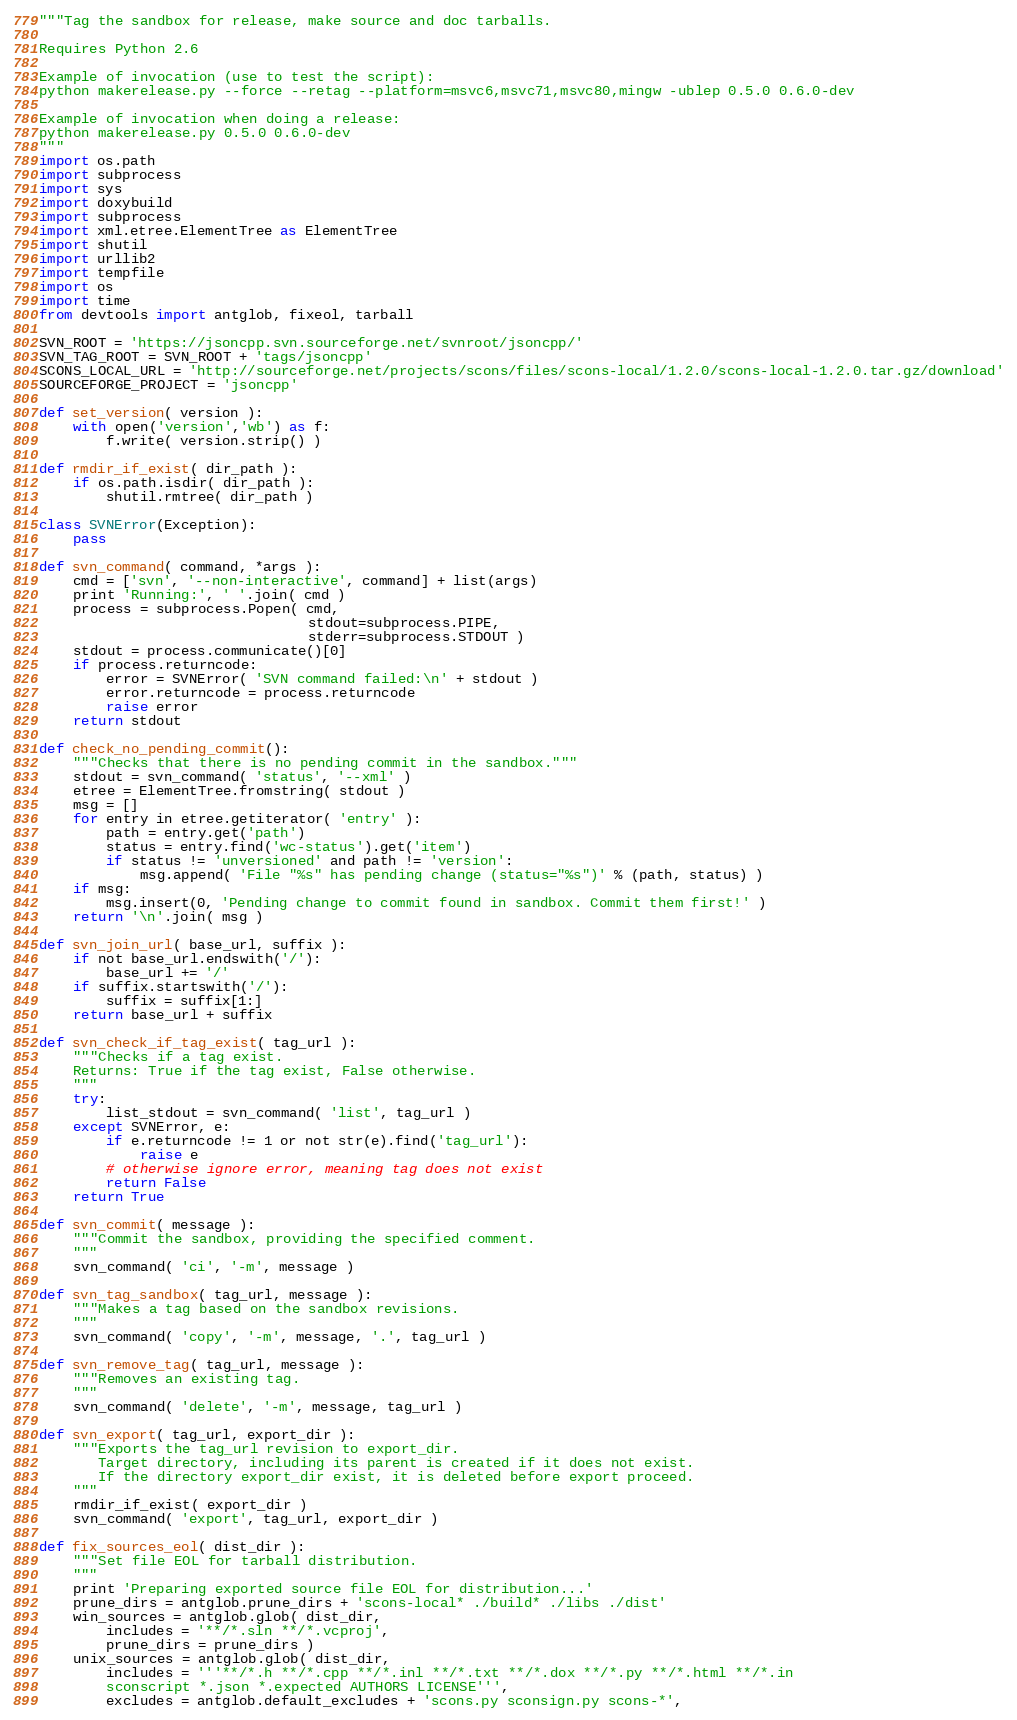Convert code to text. <code><loc_0><loc_0><loc_500><loc_500><_Python_>"""Tag the sandbox for release, make source and doc tarballs.

Requires Python 2.6

Example of invocation (use to test the script):
python makerelease.py --force --retag --platform=msvc6,msvc71,msvc80,mingw -ublep 0.5.0 0.6.0-dev

Example of invocation when doing a release:
python makerelease.py 0.5.0 0.6.0-dev
"""
import os.path
import subprocess
import sys
import doxybuild
import subprocess
import xml.etree.ElementTree as ElementTree
import shutil
import urllib2
import tempfile
import os
import time
from devtools import antglob, fixeol, tarball

SVN_ROOT = 'https://jsoncpp.svn.sourceforge.net/svnroot/jsoncpp/'
SVN_TAG_ROOT = SVN_ROOT + 'tags/jsoncpp'
SCONS_LOCAL_URL = 'http://sourceforge.net/projects/scons/files/scons-local/1.2.0/scons-local-1.2.0.tar.gz/download'
SOURCEFORGE_PROJECT = 'jsoncpp'

def set_version( version ):
    with open('version','wb') as f:
        f.write( version.strip() )

def rmdir_if_exist( dir_path ):
    if os.path.isdir( dir_path ):
        shutil.rmtree( dir_path )

class SVNError(Exception):
    pass

def svn_command( command, *args ):
    cmd = ['svn', '--non-interactive', command] + list(args)
    print 'Running:', ' '.join( cmd )
    process = subprocess.Popen( cmd,
                                stdout=subprocess.PIPE,
                                stderr=subprocess.STDOUT )
    stdout = process.communicate()[0]
    if process.returncode:
        error = SVNError( 'SVN command failed:\n' + stdout )
        error.returncode = process.returncode
        raise error
    return stdout

def check_no_pending_commit():
    """Checks that there is no pending commit in the sandbox."""
    stdout = svn_command( 'status', '--xml' )
    etree = ElementTree.fromstring( stdout )
    msg = []
    for entry in etree.getiterator( 'entry' ):
        path = entry.get('path')
        status = entry.find('wc-status').get('item')
        if status != 'unversioned' and path != 'version':
            msg.append( 'File "%s" has pending change (status="%s")' % (path, status) )
    if msg:
        msg.insert(0, 'Pending change to commit found in sandbox. Commit them first!' )
    return '\n'.join( msg )

def svn_join_url( base_url, suffix ):
    if not base_url.endswith('/'):
        base_url += '/'
    if suffix.startswith('/'):
        suffix = suffix[1:]
    return base_url + suffix

def svn_check_if_tag_exist( tag_url ):
    """Checks if a tag exist.
    Returns: True if the tag exist, False otherwise.
    """
    try:
        list_stdout = svn_command( 'list', tag_url )
    except SVNError, e:
        if e.returncode != 1 or not str(e).find('tag_url'):
            raise e
        # otherwise ignore error, meaning tag does not exist
        return False
    return True

def svn_commit( message ):
    """Commit the sandbox, providing the specified comment.
    """
    svn_command( 'ci', '-m', message )

def svn_tag_sandbox( tag_url, message ):
    """Makes a tag based on the sandbox revisions.
    """
    svn_command( 'copy', '-m', message, '.', tag_url )

def svn_remove_tag( tag_url, message ):
    """Removes an existing tag.
    """
    svn_command( 'delete', '-m', message, tag_url )

def svn_export( tag_url, export_dir ):
    """Exports the tag_url revision to export_dir.
       Target directory, including its parent is created if it does not exist.
       If the directory export_dir exist, it is deleted before export proceed.
    """
    rmdir_if_exist( export_dir )
    svn_command( 'export', tag_url, export_dir )

def fix_sources_eol( dist_dir ):
    """Set file EOL for tarball distribution.
    """
    print 'Preparing exported source file EOL for distribution...'
    prune_dirs = antglob.prune_dirs + 'scons-local* ./build* ./libs ./dist'
    win_sources = antglob.glob( dist_dir, 
        includes = '**/*.sln **/*.vcproj',
        prune_dirs = prune_dirs )
    unix_sources = antglob.glob( dist_dir,
        includes = '''**/*.h **/*.cpp **/*.inl **/*.txt **/*.dox **/*.py **/*.html **/*.in
        sconscript *.json *.expected AUTHORS LICENSE''',
        excludes = antglob.default_excludes + 'scons.py sconsign.py scons-*',</code> 